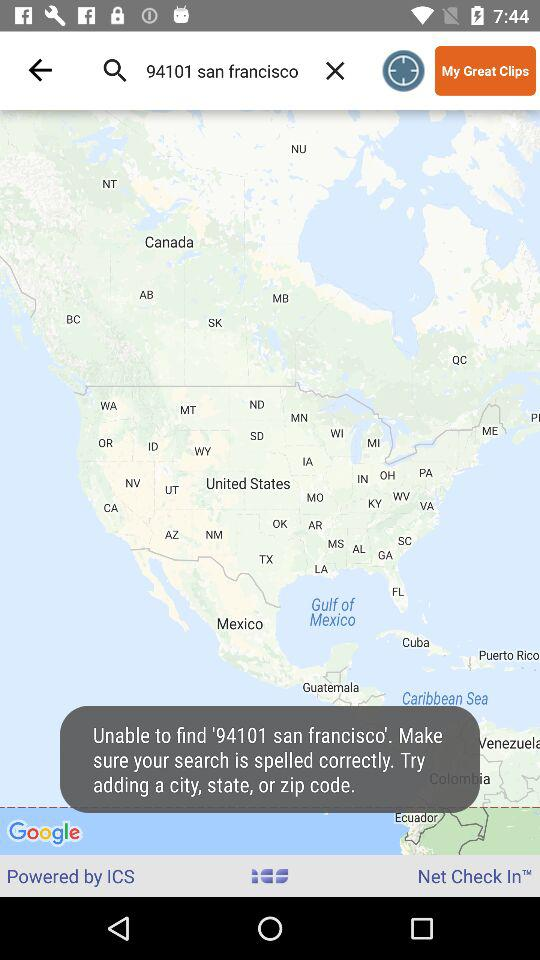What is the version number?
When the provided information is insufficient, respond with <no answer>. <no answer> 